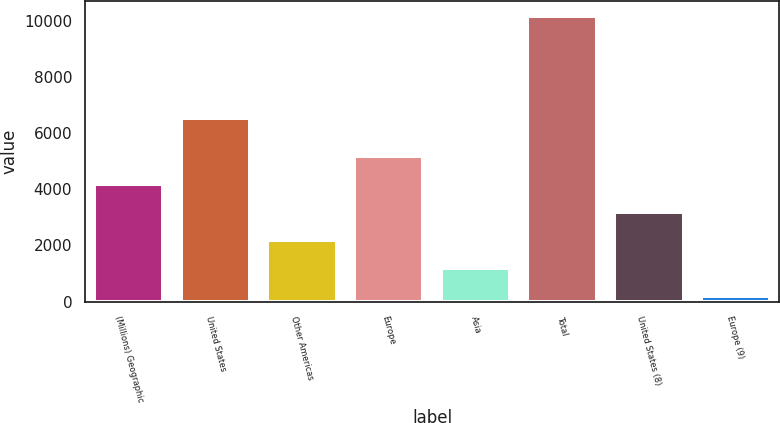Convert chart to OTSL. <chart><loc_0><loc_0><loc_500><loc_500><bar_chart><fcel>(Millions) Geographic<fcel>United States<fcel>Other Americas<fcel>Europe<fcel>Asia<fcel>Total<fcel>United States (8)<fcel>Europe (9)<nl><fcel>4197.4<fcel>6562<fcel>2196.2<fcel>5198<fcel>1195.6<fcel>10201<fcel>3196.8<fcel>195<nl></chart> 